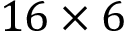<formula> <loc_0><loc_0><loc_500><loc_500>1 6 \times 6</formula> 